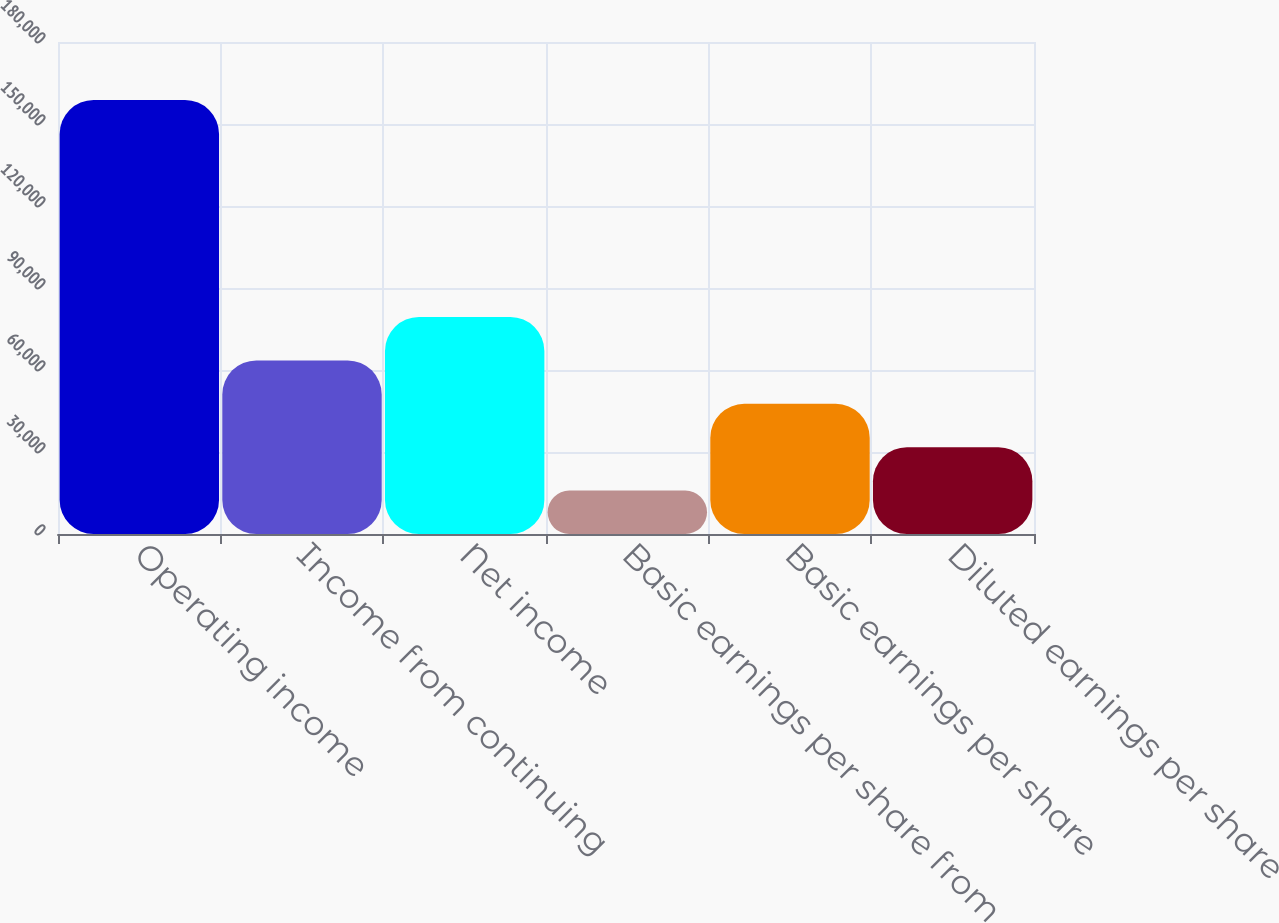Convert chart to OTSL. <chart><loc_0><loc_0><loc_500><loc_500><bar_chart><fcel>Operating income<fcel>Income from continuing<fcel>Net income<fcel>Basic earnings per share from<fcel>Basic earnings per share<fcel>Diluted earnings per share<nl><fcel>158782<fcel>63513.1<fcel>79391.3<fcel>15878.7<fcel>47635<fcel>31756.8<nl></chart> 